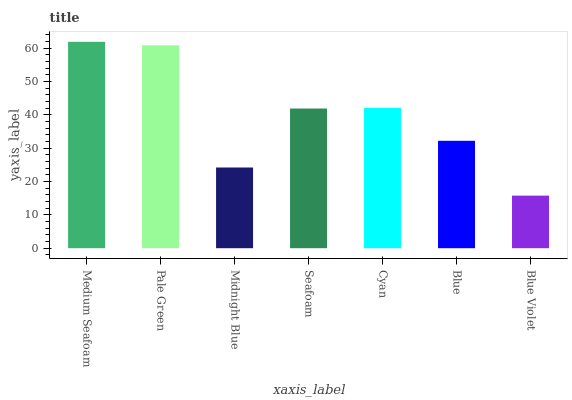Is Blue Violet the minimum?
Answer yes or no. Yes. Is Medium Seafoam the maximum?
Answer yes or no. Yes. Is Pale Green the minimum?
Answer yes or no. No. Is Pale Green the maximum?
Answer yes or no. No. Is Medium Seafoam greater than Pale Green?
Answer yes or no. Yes. Is Pale Green less than Medium Seafoam?
Answer yes or no. Yes. Is Pale Green greater than Medium Seafoam?
Answer yes or no. No. Is Medium Seafoam less than Pale Green?
Answer yes or no. No. Is Seafoam the high median?
Answer yes or no. Yes. Is Seafoam the low median?
Answer yes or no. Yes. Is Blue the high median?
Answer yes or no. No. Is Pale Green the low median?
Answer yes or no. No. 